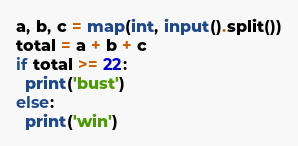Convert code to text. <code><loc_0><loc_0><loc_500><loc_500><_Python_>a, b, c = map(int, input().split())
total = a + b + c
if total >= 22:
  print('bust')
else:
  print('win')</code> 